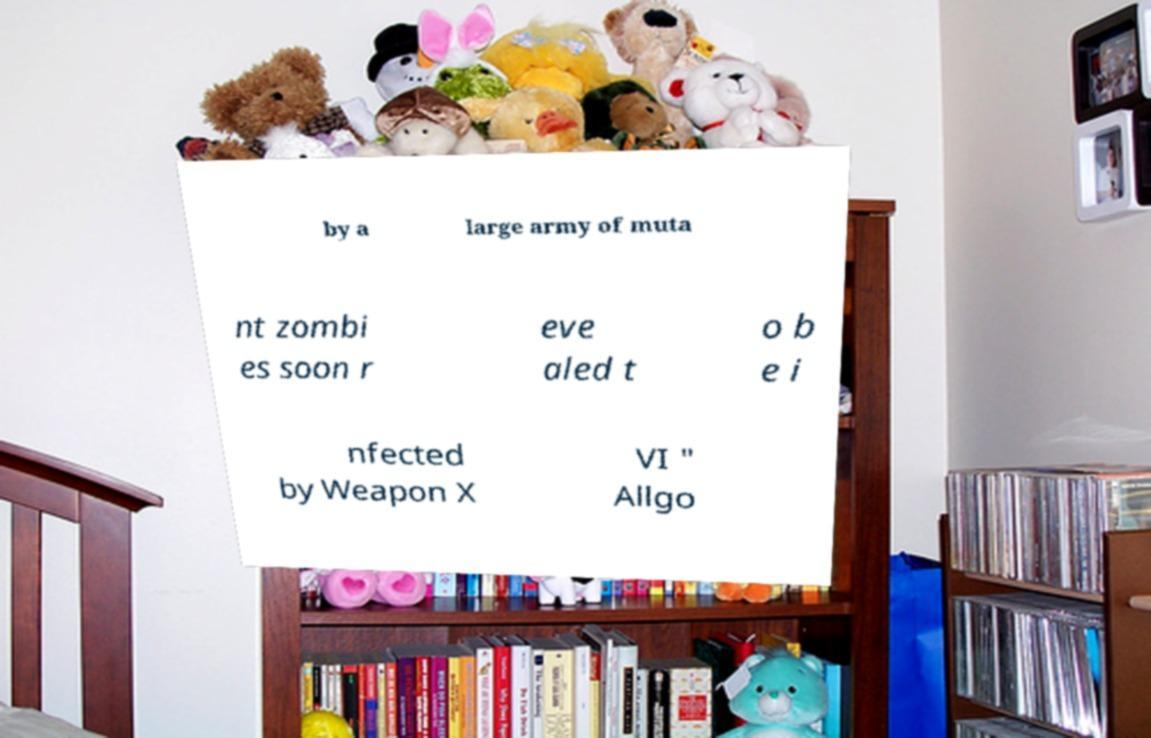Please identify and transcribe the text found in this image. by a large army of muta nt zombi es soon r eve aled t o b e i nfected by Weapon X VI " Allgo 